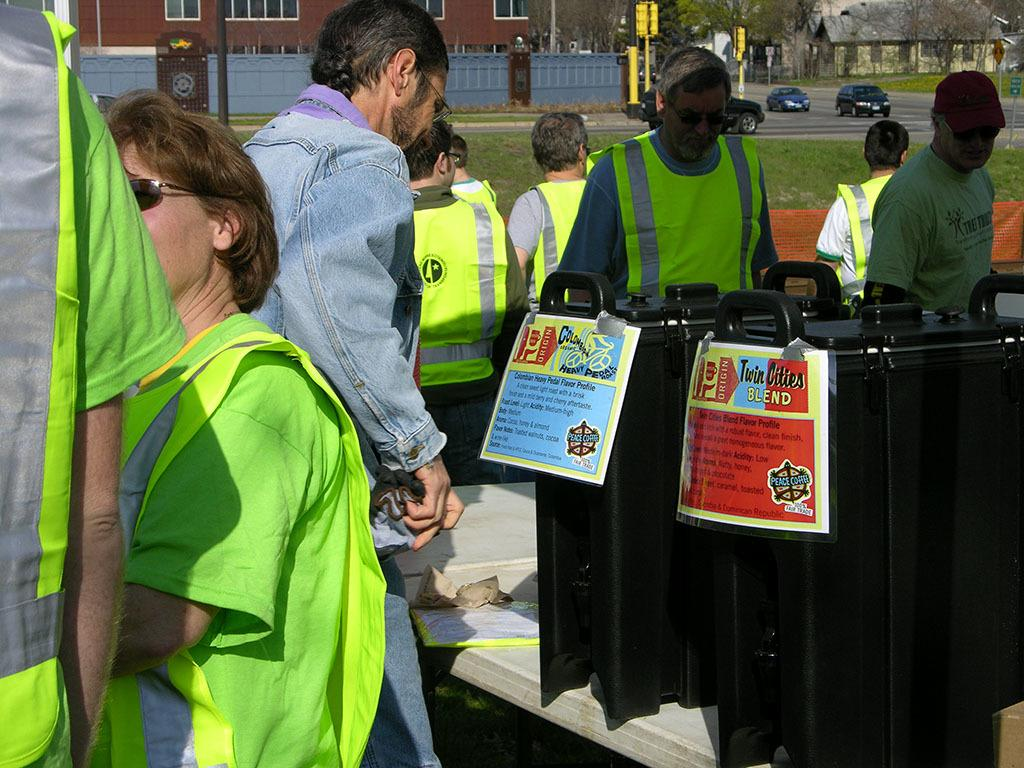<image>
Describe the image concisely. A group where a man is reading a sign from Twin Cities Blend. 